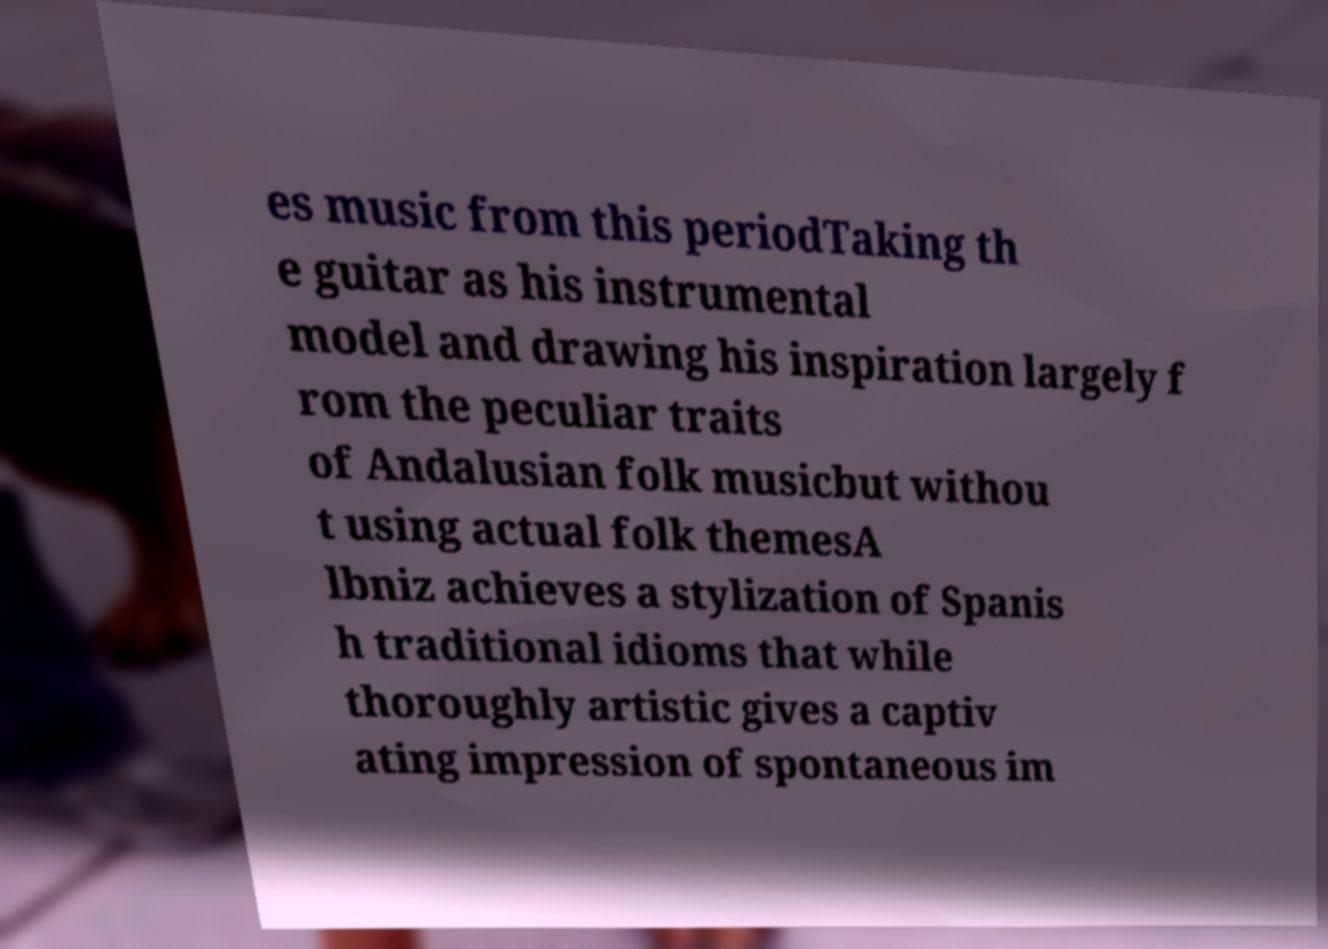Could you assist in decoding the text presented in this image and type it out clearly? es music from this periodTaking th e guitar as his instrumental model and drawing his inspiration largely f rom the peculiar traits of Andalusian folk musicbut withou t using actual folk themesA lbniz achieves a stylization of Spanis h traditional idioms that while thoroughly artistic gives a captiv ating impression of spontaneous im 